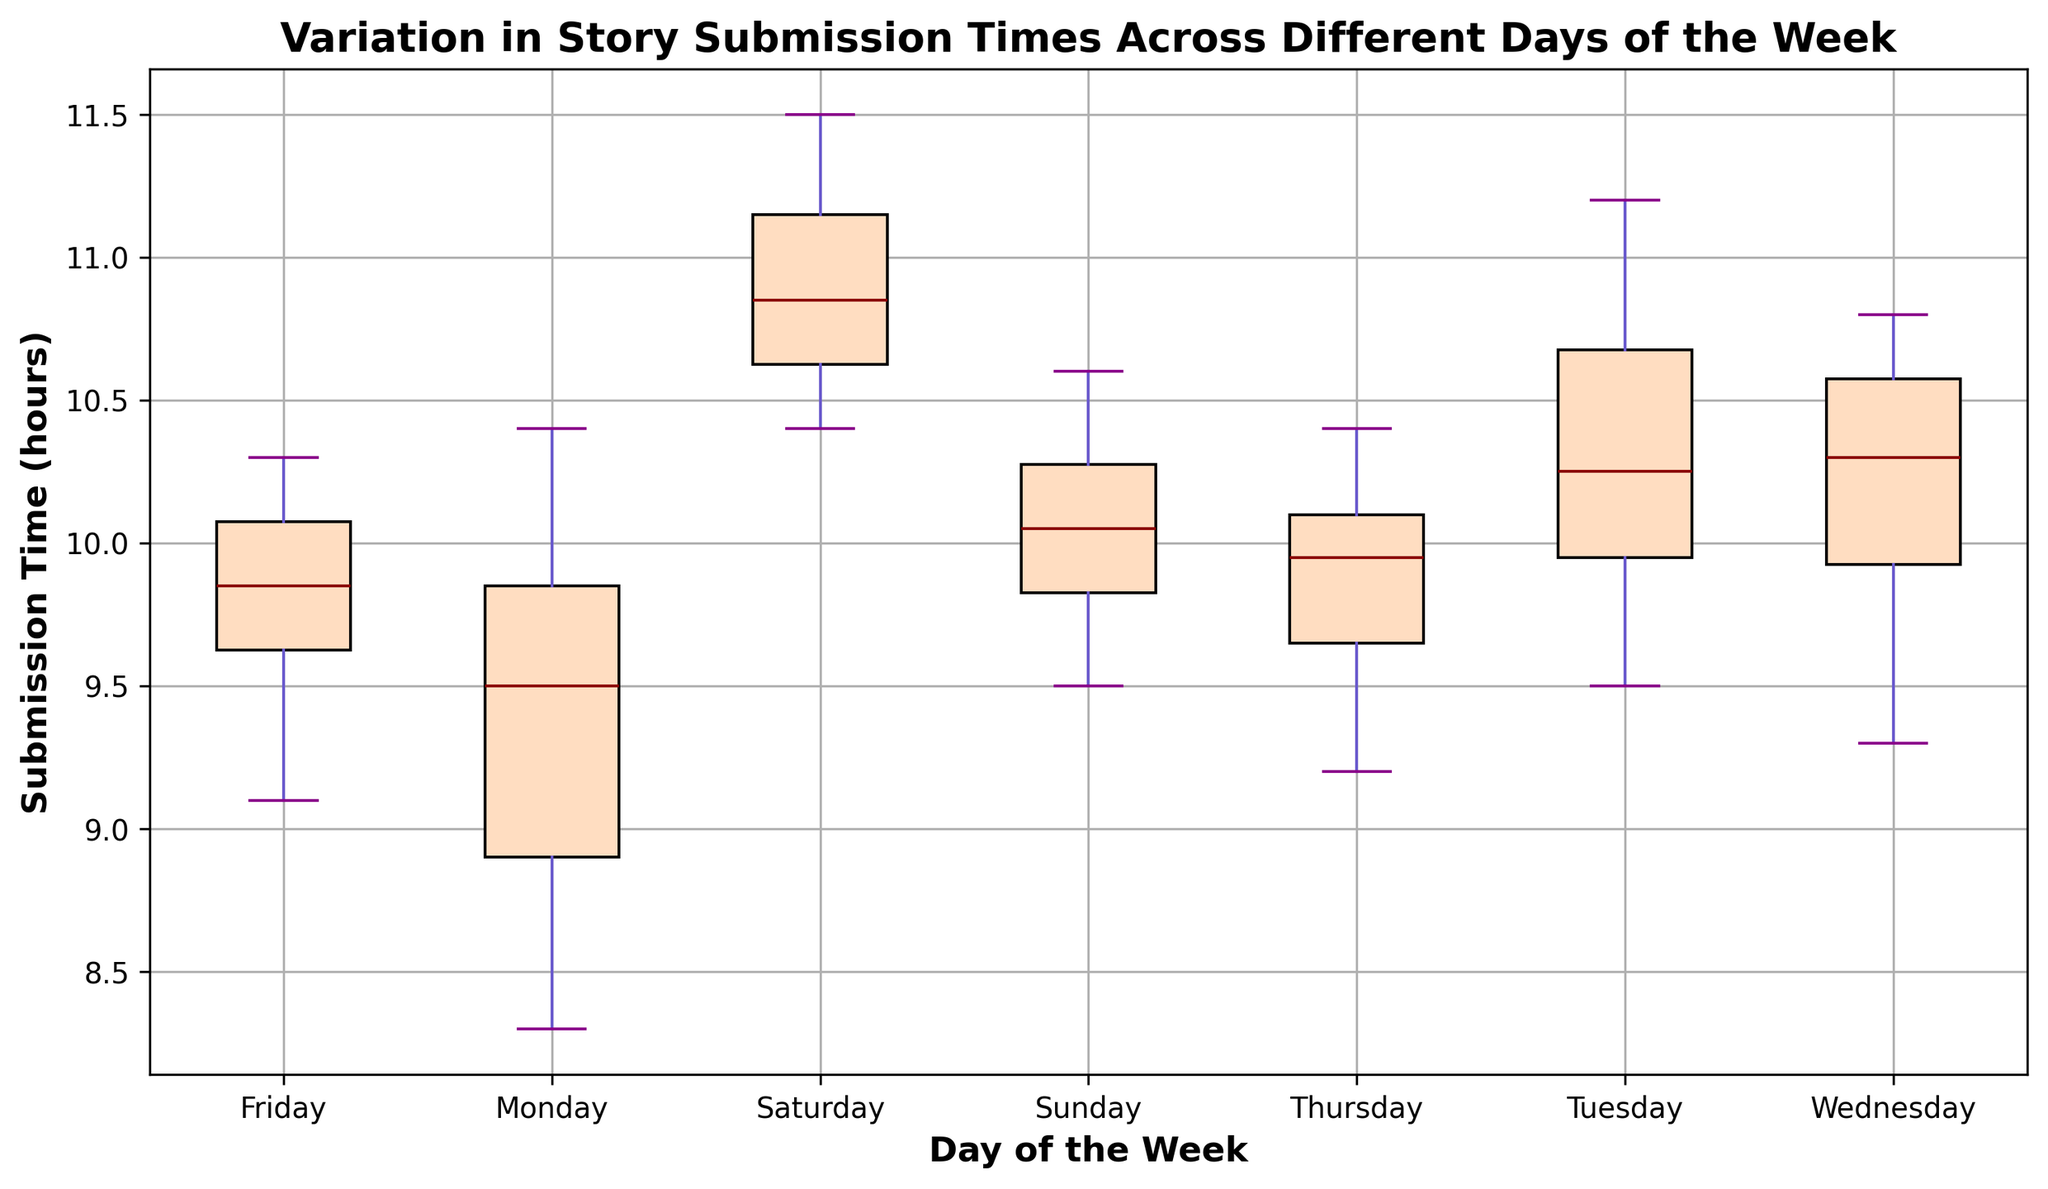Which day has the highest median submission time? In the box plot, the median is represented by the line inside the box for each day. Look for the day where this line is the highest.
Answer: Saturday Which day has the lowest median submission time? The median line is the lowest for Monday among all days, indicating it has the lowest median submission time.
Answer: Monday How does the interquartile range (IQR) of Sunday compare to that of Tuesday? The IQR is the length of the box, which represents the range between the first quartile (Q1) and the third quartile (Q3). Visually compare the box lengths for Sunday and Tuesday.
Answer: Sunday's IQR is larger than Tuesday's On which days are there any potential outliers in the submission times? Outliers are typically represented by dots outside the whiskers of the box plot. Check for dots beyond the whiskers for all days.
Answer: There are no clear outliers Which day shows the most variability in submission times? Variability can be observed by looking at the total span of the whiskers. The day with the longest whiskers or the largest distance between the smallest and largest values indicates the most variability.
Answer: Saturday Is there any day where the median submission time is higher than the upper quartile of Monday? First, identify Monday's upper quartile (top of the box) and then check if the median line of any other day is above this value.
Answer: Yes, Saturday and Wednesday Compare the maximum submission times of Friday and Wednesday. Which is higher? The maximum submission time is the top whisker. Compare the top whiskers of Friday and Wednesday to see which one is higher.
Answer: Wednesday What is the relationship between the central tendency (median) of Sunday and Thursday? Compare the positions of the median lines for both Sunday and Thursday within their respective boxes.
Answer: Sunday and Thursday have similar medians Which day shows the least variability in submission times? Least variability is indicated by the shortest whiskers. Check for the day with the shortest distance between the smallest and largest values.
Answer: Monday Which two days have the closest median submission times? Compare the lines within the boxes for all days and find the pair whose lines are closest to each other.
Answer: Thursday and Sunday 